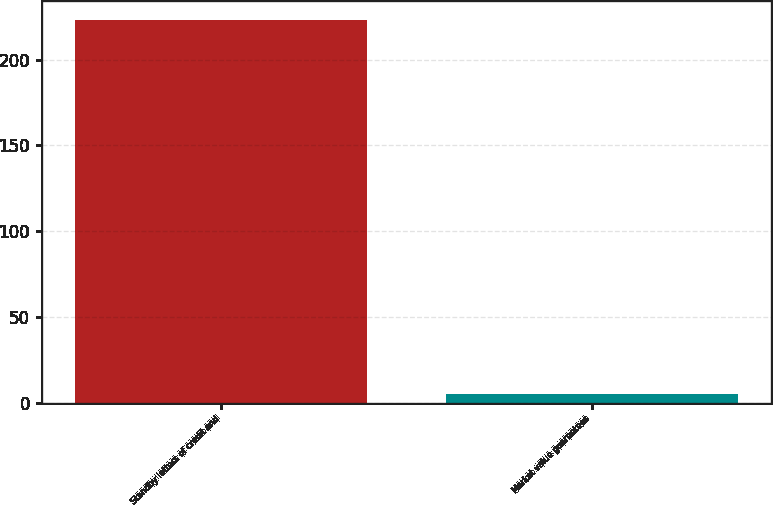<chart> <loc_0><loc_0><loc_500><loc_500><bar_chart><fcel>Standby letters of credit and<fcel>Market value guarantees<nl><fcel>223<fcel>5<nl></chart> 